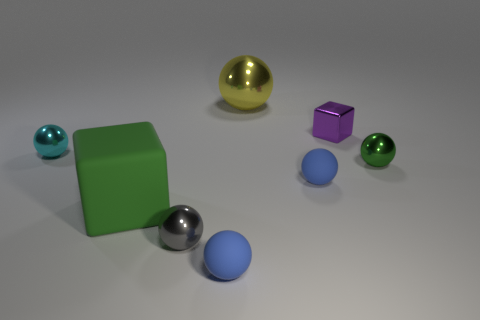Subtract all gray balls. How many balls are left? 5 Subtract all yellow shiny balls. How many balls are left? 5 Subtract 1 spheres. How many spheres are left? 5 Subtract all purple balls. Subtract all red blocks. How many balls are left? 6 Add 2 small yellow things. How many objects exist? 10 Subtract all spheres. How many objects are left? 2 Subtract all tiny cyan balls. Subtract all large objects. How many objects are left? 5 Add 2 small purple metal things. How many small purple metal things are left? 3 Add 4 small matte things. How many small matte things exist? 6 Subtract 0 red cylinders. How many objects are left? 8 